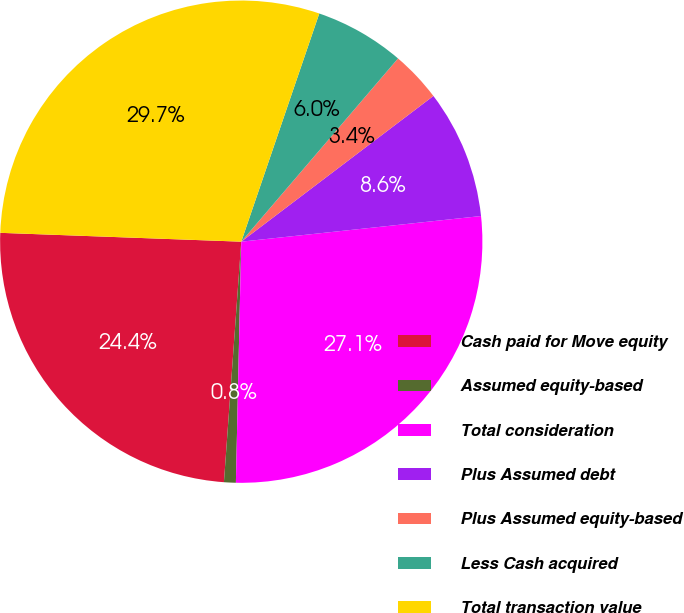Convert chart. <chart><loc_0><loc_0><loc_500><loc_500><pie_chart><fcel>Cash paid for Move equity<fcel>Assumed equity-based<fcel>Total consideration<fcel>Plus Assumed debt<fcel>Plus Assumed equity-based<fcel>Less Cash acquired<fcel>Total transaction value<nl><fcel>24.44%<fcel>0.79%<fcel>27.05%<fcel>8.63%<fcel>3.41%<fcel>6.02%<fcel>29.66%<nl></chart> 